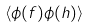Convert formula to latex. <formula><loc_0><loc_0><loc_500><loc_500>\langle \phi ( f ) \phi ( h ) \rangle</formula> 